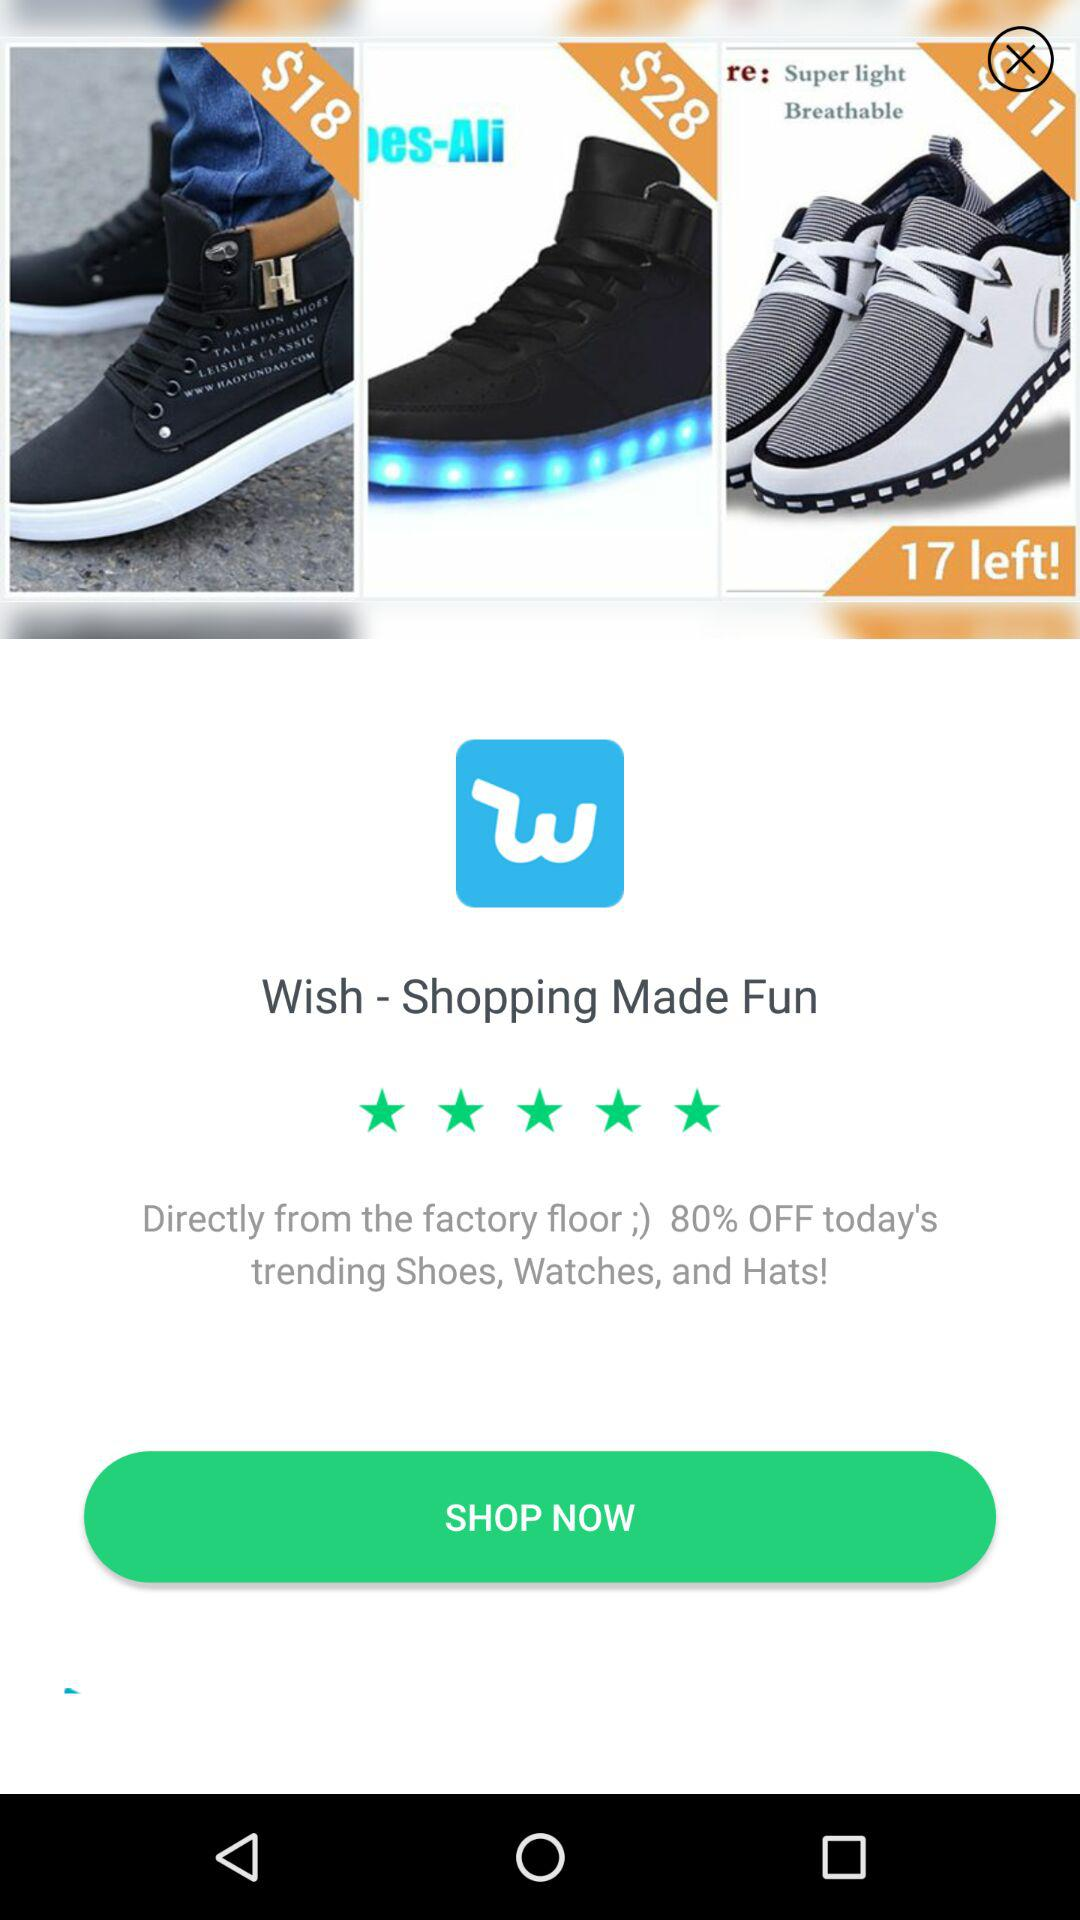How many items are left? There are 17 items left. 